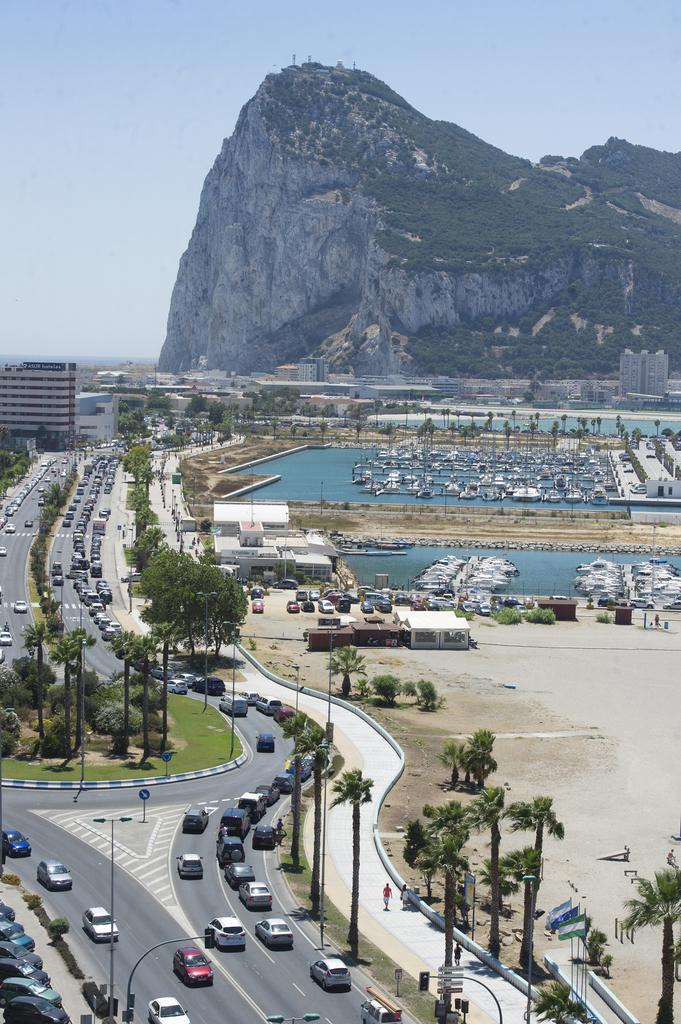What type of view is provided in the image? The image is a top view of a city. What is happening on the roads in the image? Cars are passing on the road in the image. What type of vegetation can be seen in the image? There are trees in the image. What body of water is visible in the image? There is water visible in the image, and boats are present in it. What type of structures are present in the image? There are buildings in the image. What geographical feature can be seen in the background of the image? There is a mountain in the background of the image. What type of weather can be seen in the image? The image does not provide information about the weather; it only shows a top view of a city with various elements. What type of humor is present in the image? The image does not contain any humor; it is a straightforward representation of a city. What type of disease is affecting the trees in the image? The image does not mention any disease affecting the trees; it only shows trees as part of the city's landscape. 